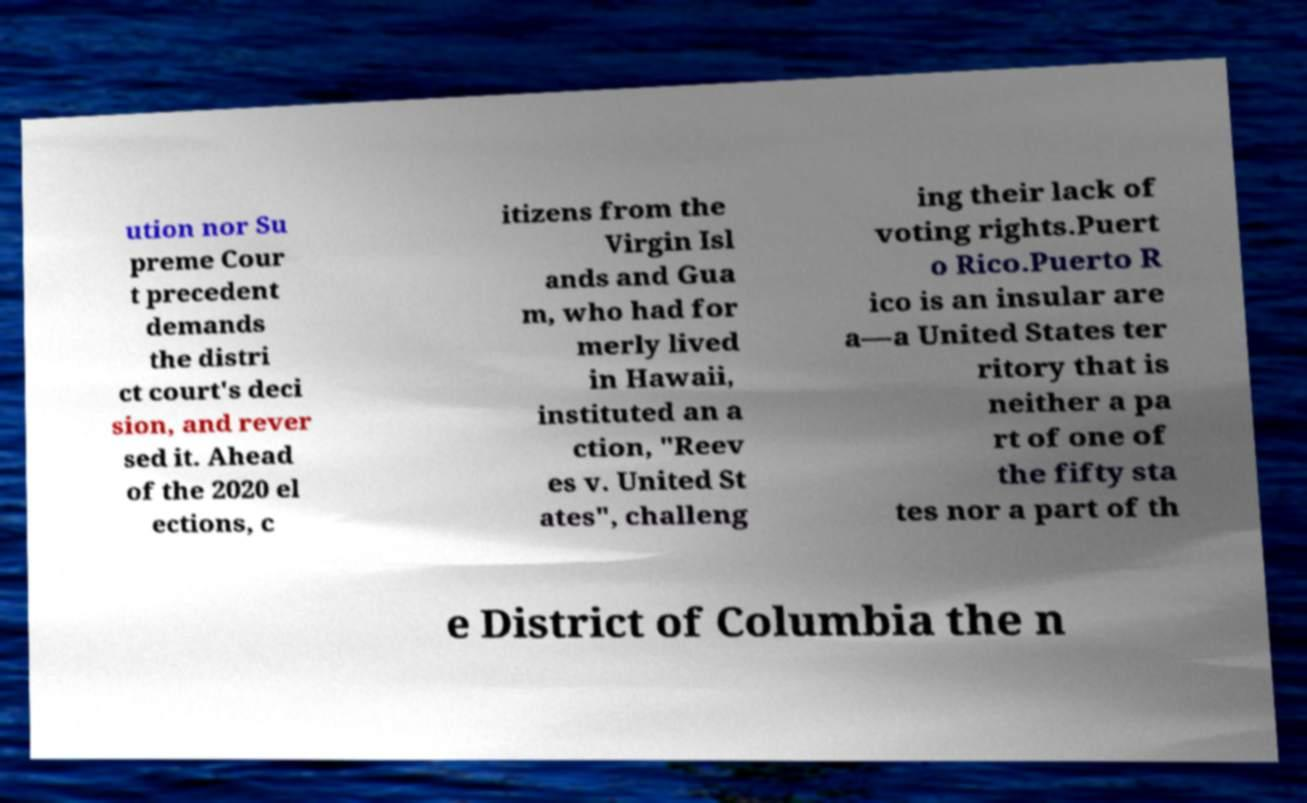Please read and relay the text visible in this image. What does it say? ution nor Su preme Cour t precedent demands the distri ct court's deci sion, and rever sed it. Ahead of the 2020 el ections, c itizens from the Virgin Isl ands and Gua m, who had for merly lived in Hawaii, instituted an a ction, "Reev es v. United St ates", challeng ing their lack of voting rights.Puert o Rico.Puerto R ico is an insular are a—a United States ter ritory that is neither a pa rt of one of the fifty sta tes nor a part of th e District of Columbia the n 